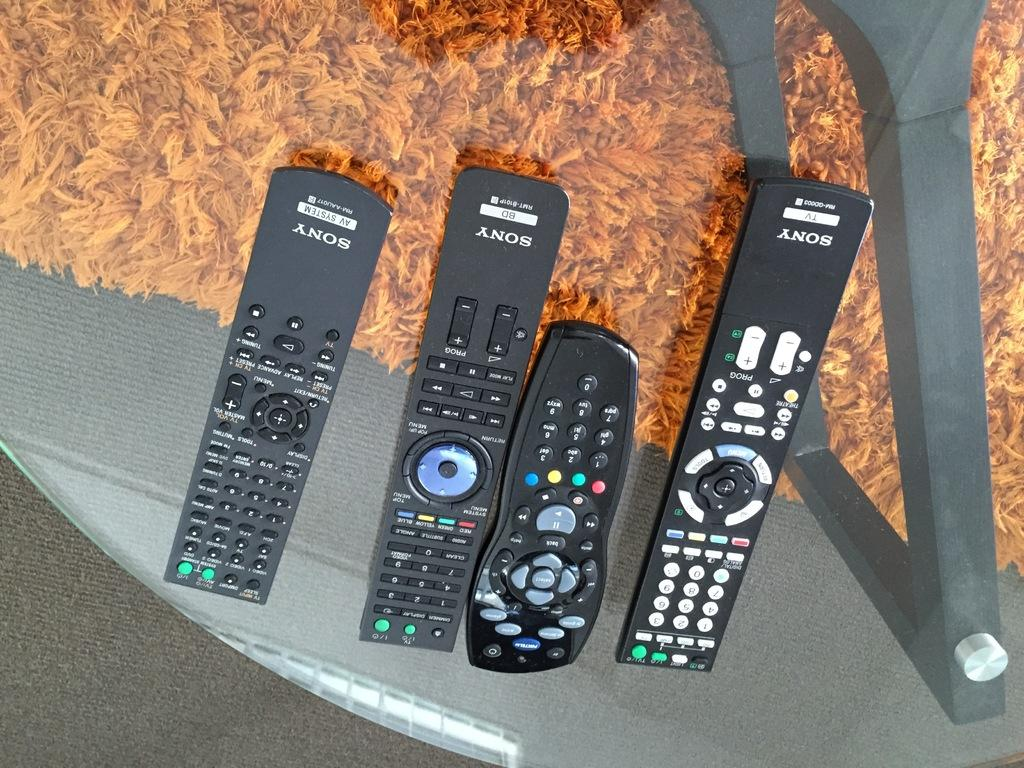Provide a one-sentence caption for the provided image. A collection of Sony remote controls are displayed over an orange rug. 